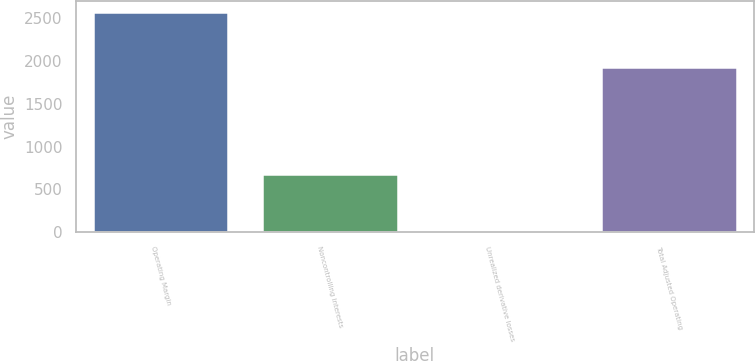Convert chart to OTSL. <chart><loc_0><loc_0><loc_500><loc_500><bar_chart><fcel>Operating Margin<fcel>Noncontrolling interests<fcel>Unrealized derivative losses<fcel>Total Adjusted Operating<nl><fcel>2573<fcel>686<fcel>19<fcel>1928<nl></chart> 